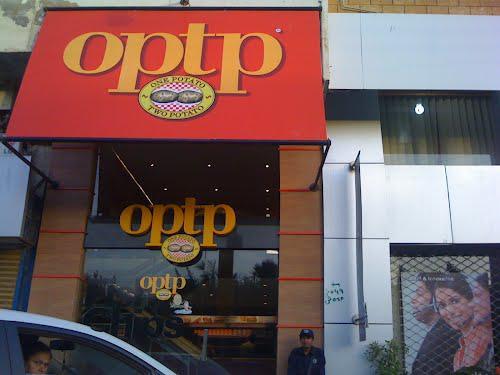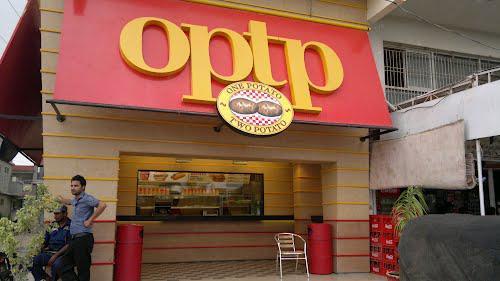The first image is the image on the left, the second image is the image on the right. Assess this claim about the two images: "There are at least three cars in one image.". Correct or not? Answer yes or no. No. The first image is the image on the left, the second image is the image on the right. Assess this claim about the two images: "There are people in both images.". Correct or not? Answer yes or no. Yes. 